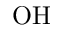Convert formula to latex. <formula><loc_0><loc_0><loc_500><loc_500>O H</formula> 